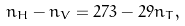<formula> <loc_0><loc_0><loc_500><loc_500>n _ { H } - n _ { V } = 2 7 3 - 2 9 n _ { T } ,</formula> 